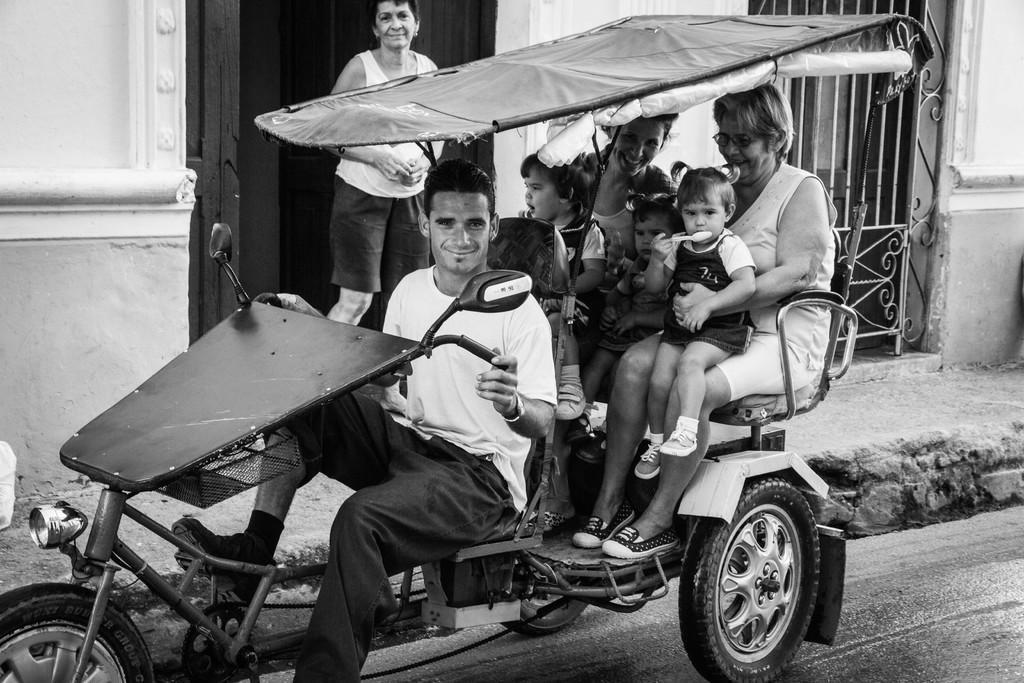Please provide a concise description of this image. This is a black and white image ,where in the middle there is a vehicle with light and handle, a woman in the middle is driving that vehicle ,is smiling and back side there are two women and three kids, one woman standing back side of that vehicle beside that woman there is an iron gate. This vehicle has light and wheels. 